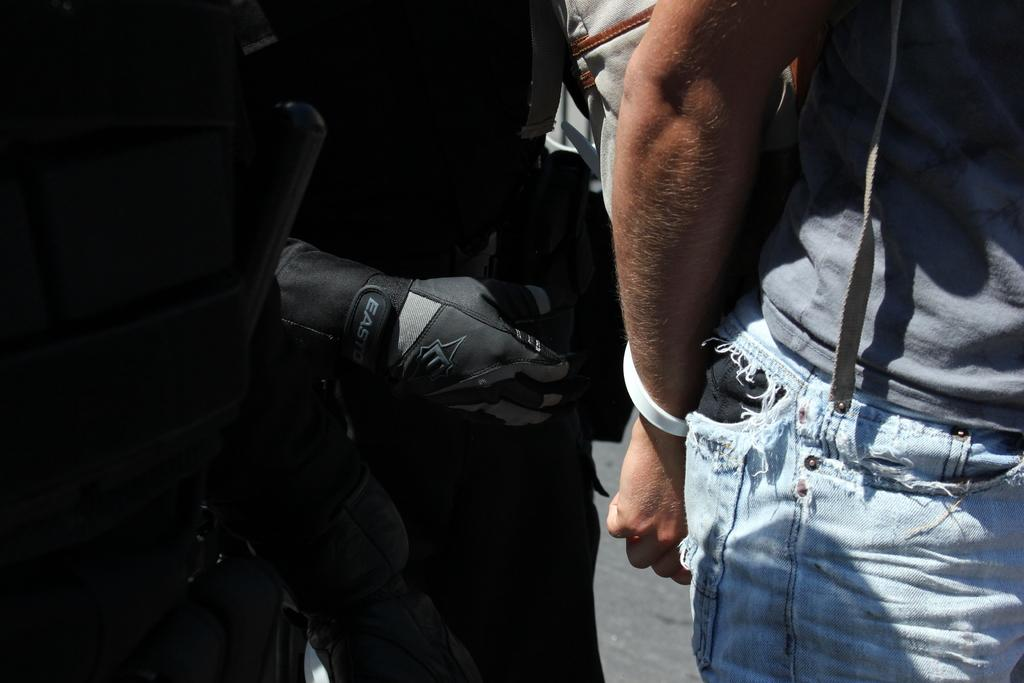How many people are in the image? There are two persons standing in the image. Can you describe the clothing of one of the persons? One person is wearing a gray and blue color dress. Is the person wearing a veil in the image? There is no mention of a veil in the provided facts, and therefore it cannot be determined if the person is wearing one. 